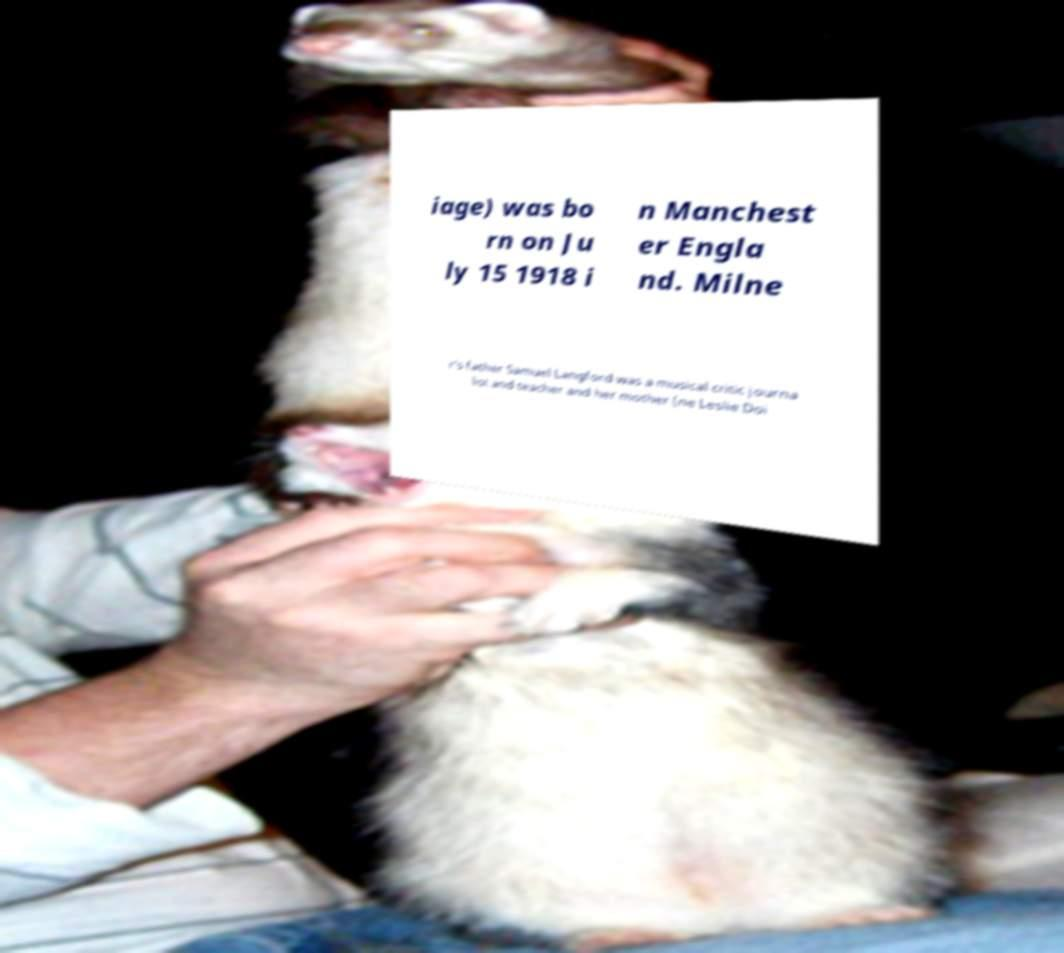Please identify and transcribe the text found in this image. iage) was bo rn on Ju ly 15 1918 i n Manchest er Engla nd. Milne r's father Samuel Langford was a musical critic journa list and teacher and her mother (ne Leslie Doi 